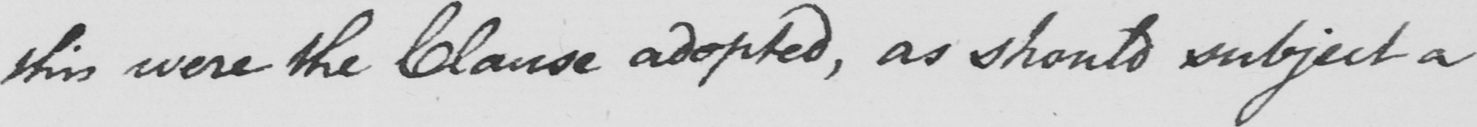Please provide the text content of this handwritten line. this were the Clause adopted , as should subject a 